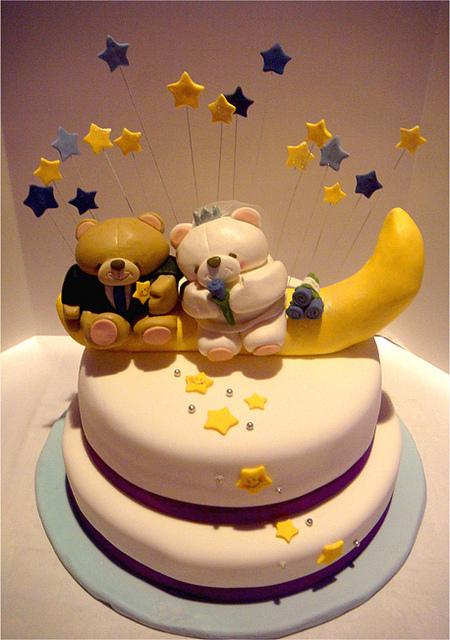Is the cake real or fake?
Concise answer only. Real. What fruit is on top of the cake?
Keep it brief. Banana. What is this cake for?
Concise answer only. Wedding. What is this?
Concise answer only. Cake. 